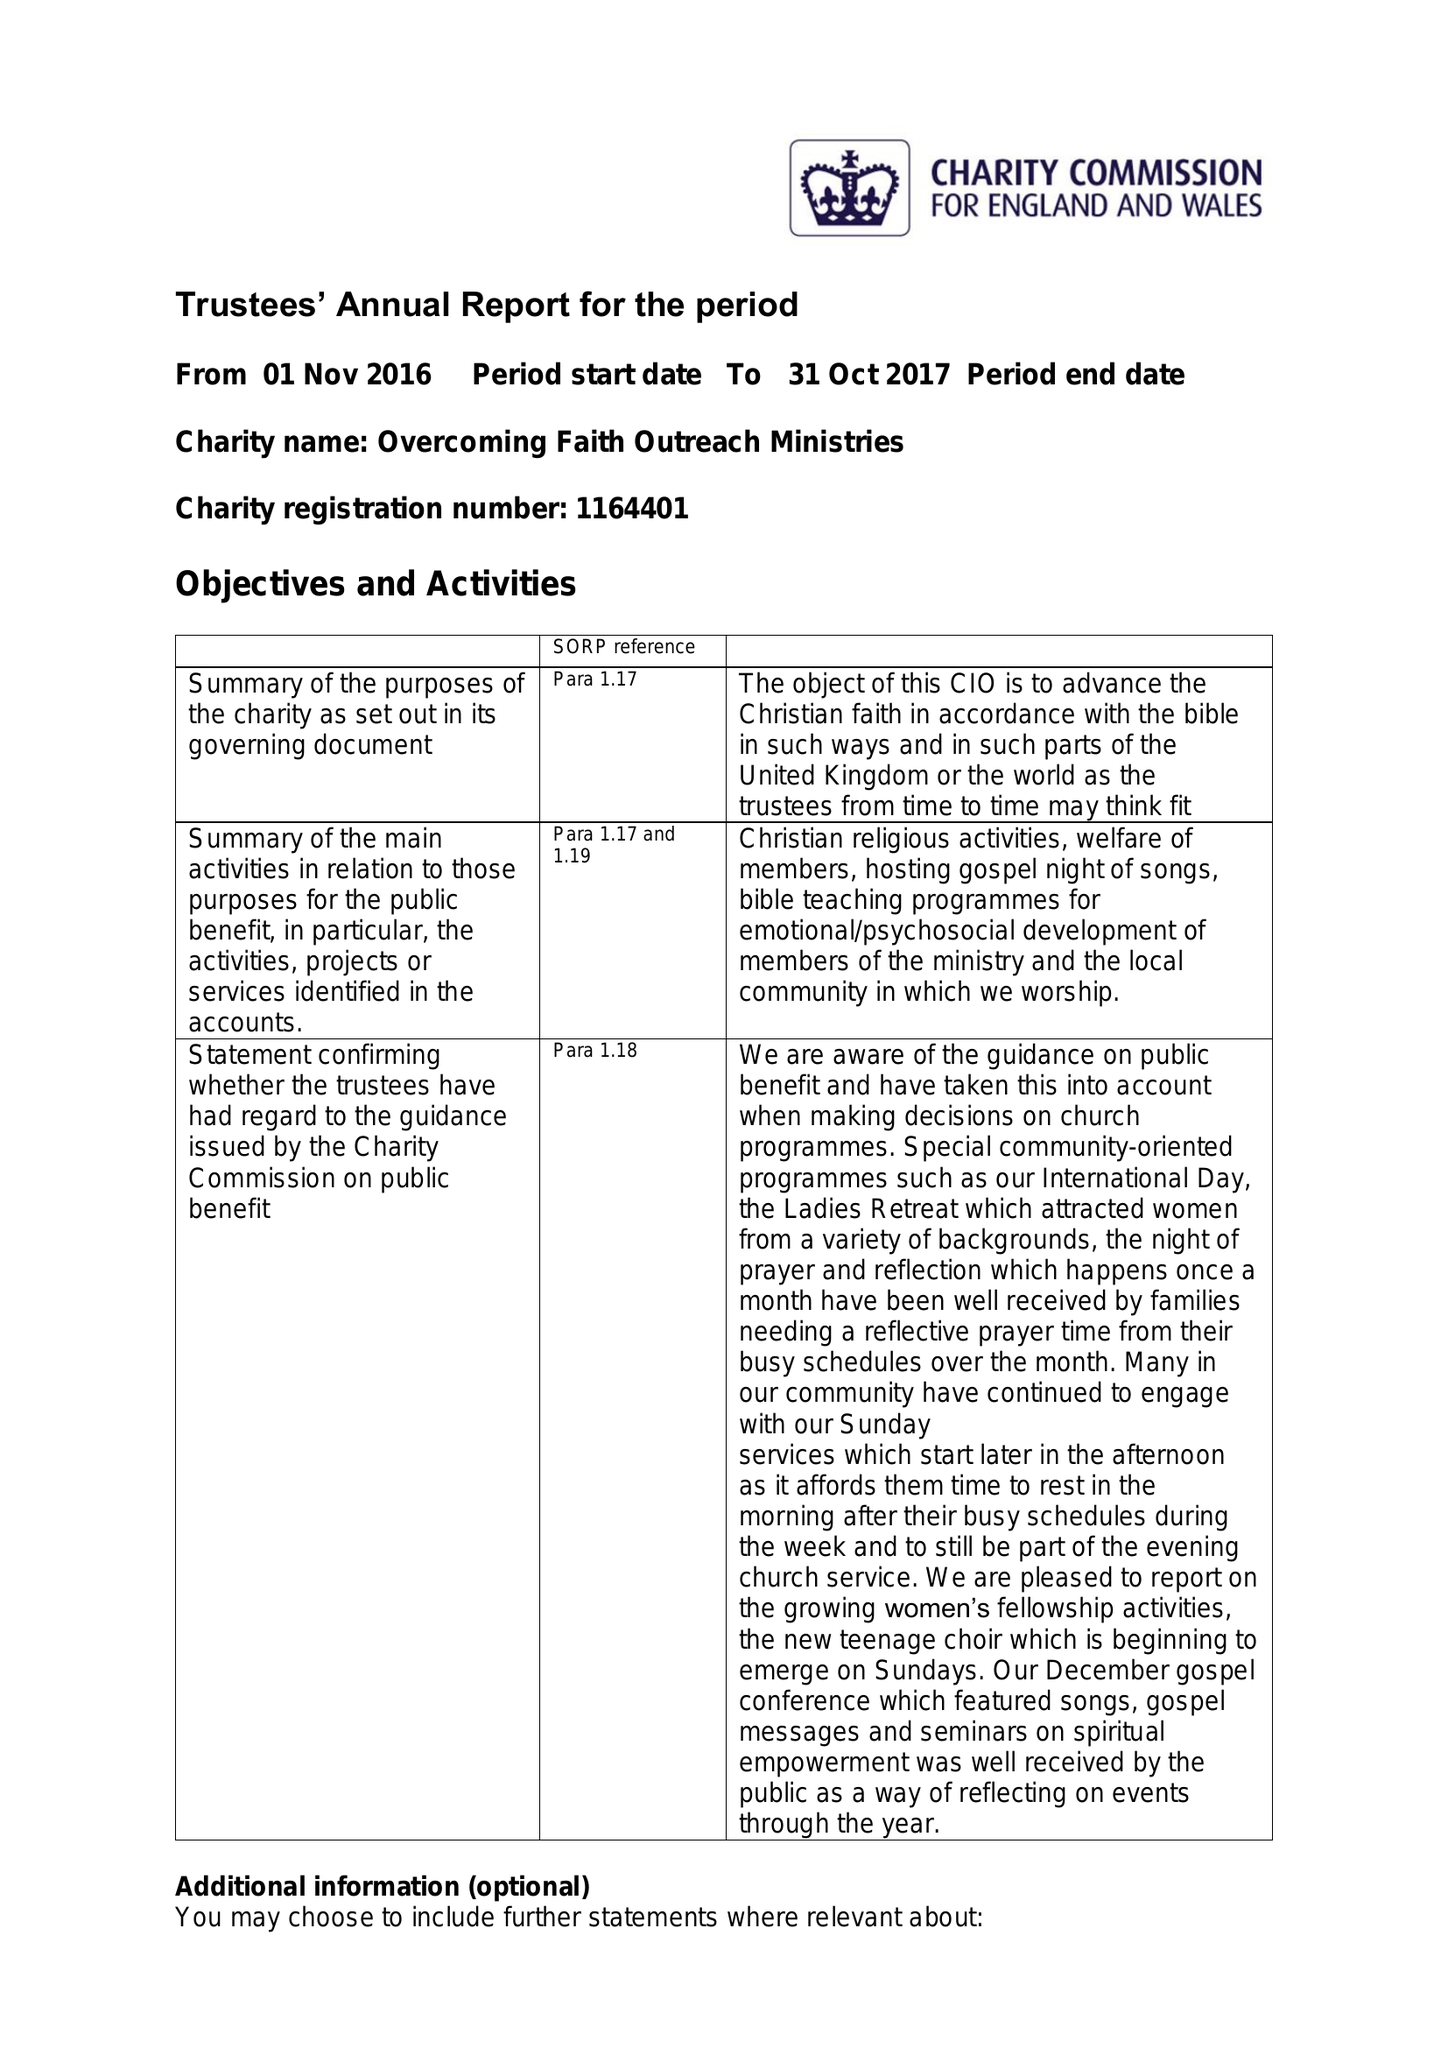What is the value for the spending_annually_in_british_pounds?
Answer the question using a single word or phrase. 24614.00 